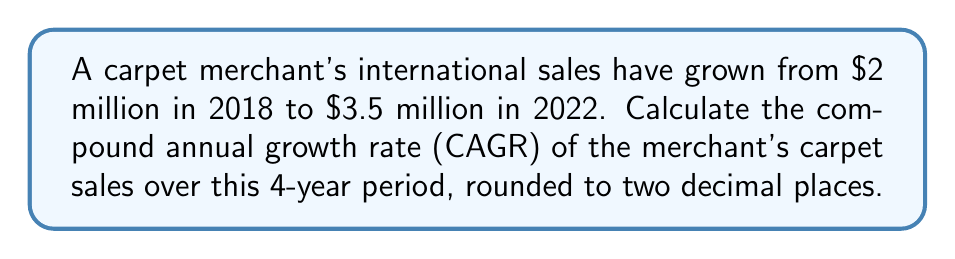Teach me how to tackle this problem. To calculate the Compound Annual Growth Rate (CAGR), we use the formula:

$$ CAGR = \left(\frac{Ending Value}{Beginning Value}\right)^{\frac{1}{n}} - 1 $$

Where:
- Ending Value = $3.5 million
- Beginning Value = $2 million
- n = number of years = 4

Let's substitute these values into the formula:

$$ CAGR = \left(\frac{3.5}{2}\right)^{\frac{1}{4}} - 1 $$

Now, let's solve step-by-step:

1) First, calculate the fraction inside the parentheses:
   $\frac{3.5}{2} = 1.75$

2) Now, our equation looks like this:
   $$ CAGR = (1.75)^{\frac{1}{4}} - 1 $$

3) Calculate the fourth root of 1.75:
   $(1.75)^{\frac{1}{4}} \approx 1.1486$

4) Subtract 1:
   $1.1486 - 1 = 0.1486$

5) Convert to a percentage:
   $0.1486 \times 100 = 14.86\%$

6) Round to two decimal places:
   $14.86\% \approx 14.86\%$

Therefore, the compound annual growth rate is 14.86%.
Answer: 14.86% 